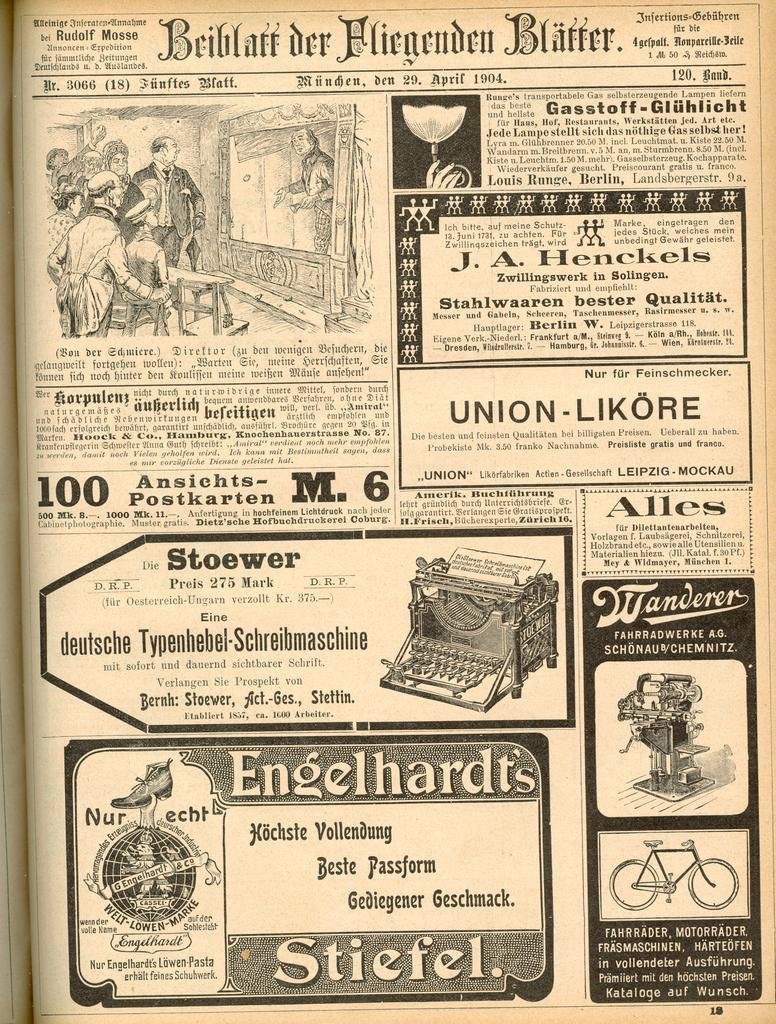Provide a one-sentence caption for the provided image. A German paper displays many such as for Engelhardt's boots or Stoewer typewriters. 